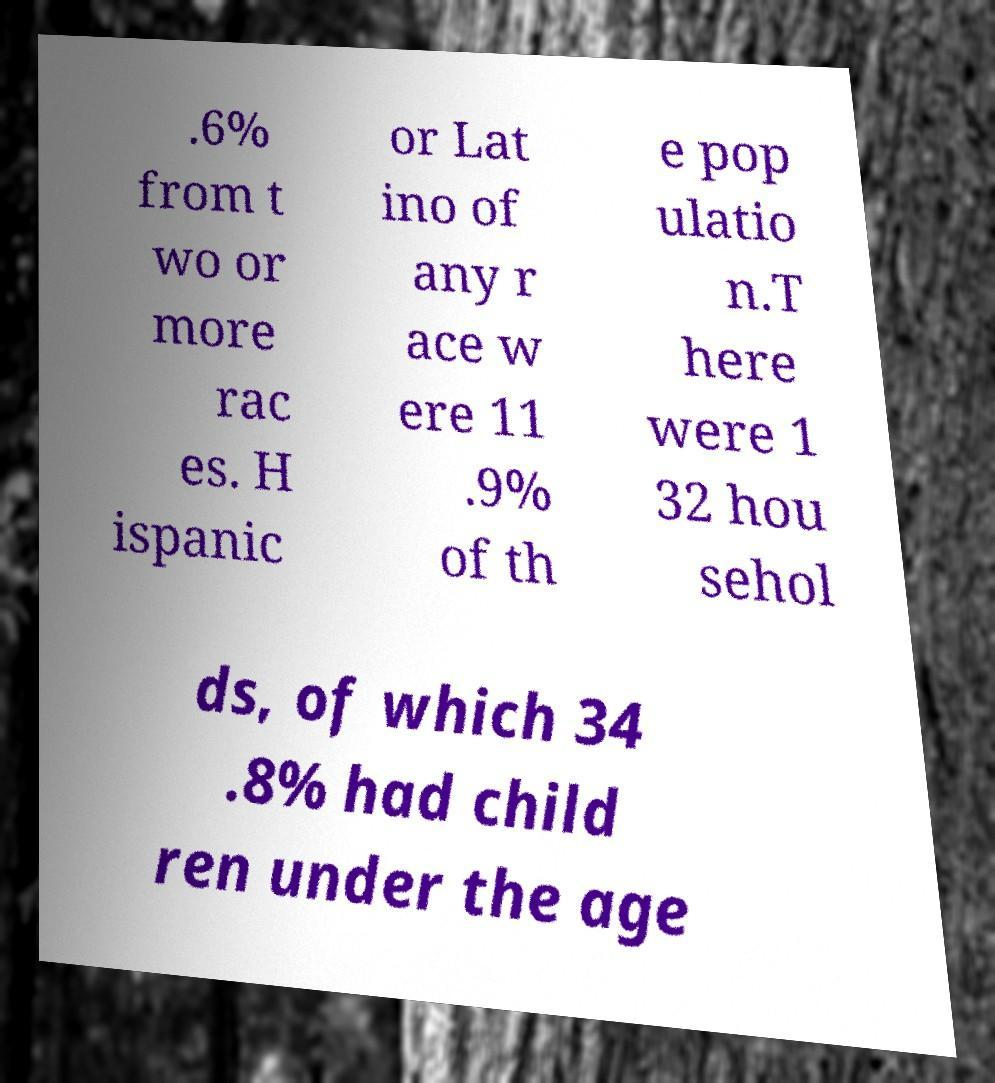For documentation purposes, I need the text within this image transcribed. Could you provide that? .6% from t wo or more rac es. H ispanic or Lat ino of any r ace w ere 11 .9% of th e pop ulatio n.T here were 1 32 hou sehol ds, of which 34 .8% had child ren under the age 